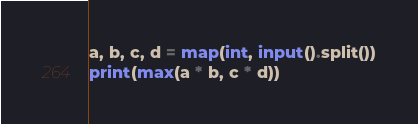<code> <loc_0><loc_0><loc_500><loc_500><_Python_>a, b, c, d = map(int, input().split())
print(max(a * b, c * d))
</code> 